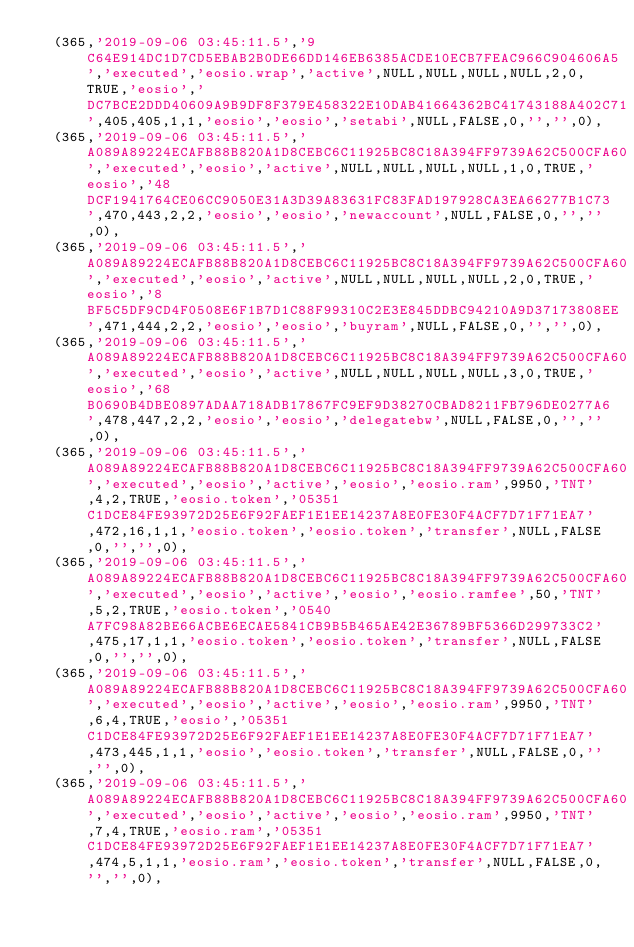Convert code to text. <code><loc_0><loc_0><loc_500><loc_500><_SQL_>  (365,'2019-09-06 03:45:11.5','9C64E914DC1D7CD5EBAB2B0DE66DD146EB6385ACDE10ECB7FEAC966C904606A5','executed','eosio.wrap','active',NULL,NULL,NULL,NULL,2,0,TRUE,'eosio','DC7BCE2DDD40609A9B9DF8F379E458322E10DAB41664362BC41743188A402C71',405,405,1,1,'eosio','eosio','setabi',NULL,FALSE,0,'','',0),
  (365,'2019-09-06 03:45:11.5','A089A89224ECAFB88B820A1D8CEBC6C11925BC8C18A394FF9739A62C500CFA60','executed','eosio','active',NULL,NULL,NULL,NULL,1,0,TRUE,'eosio','48DCF1941764CE06CC9050E31A3D39A83631FC83FAD197928CA3EA66277B1C73',470,443,2,2,'eosio','eosio','newaccount',NULL,FALSE,0,'','',0),
  (365,'2019-09-06 03:45:11.5','A089A89224ECAFB88B820A1D8CEBC6C11925BC8C18A394FF9739A62C500CFA60','executed','eosio','active',NULL,NULL,NULL,NULL,2,0,TRUE,'eosio','8BF5C5DF9CD4F0508E6F1B7D1C88F99310C2E3E845DDBC94210A9D37173808EE',471,444,2,2,'eosio','eosio','buyram',NULL,FALSE,0,'','',0),
  (365,'2019-09-06 03:45:11.5','A089A89224ECAFB88B820A1D8CEBC6C11925BC8C18A394FF9739A62C500CFA60','executed','eosio','active',NULL,NULL,NULL,NULL,3,0,TRUE,'eosio','68B0690B4DBE0897ADAA718ADB17867FC9EF9D38270CBAD8211FB796DE0277A6',478,447,2,2,'eosio','eosio','delegatebw',NULL,FALSE,0,'','',0),
  (365,'2019-09-06 03:45:11.5','A089A89224ECAFB88B820A1D8CEBC6C11925BC8C18A394FF9739A62C500CFA60','executed','eosio','active','eosio','eosio.ram',9950,'TNT',4,2,TRUE,'eosio.token','05351C1DCE84FE93972D25E6F92FAEF1E1EE14237A8E0FE30F4ACF7D71F71EA7',472,16,1,1,'eosio.token','eosio.token','transfer',NULL,FALSE,0,'','',0),
  (365,'2019-09-06 03:45:11.5','A089A89224ECAFB88B820A1D8CEBC6C11925BC8C18A394FF9739A62C500CFA60','executed','eosio','active','eosio','eosio.ramfee',50,'TNT',5,2,TRUE,'eosio.token','0540A7FC98A82BE66ACBE6ECAE5841CB9B5B465AE42E36789BF5366D299733C2',475,17,1,1,'eosio.token','eosio.token','transfer',NULL,FALSE,0,'','',0),
  (365,'2019-09-06 03:45:11.5','A089A89224ECAFB88B820A1D8CEBC6C11925BC8C18A394FF9739A62C500CFA60','executed','eosio','active','eosio','eosio.ram',9950,'TNT',6,4,TRUE,'eosio','05351C1DCE84FE93972D25E6F92FAEF1E1EE14237A8E0FE30F4ACF7D71F71EA7',473,445,1,1,'eosio','eosio.token','transfer',NULL,FALSE,0,'','',0),
  (365,'2019-09-06 03:45:11.5','A089A89224ECAFB88B820A1D8CEBC6C11925BC8C18A394FF9739A62C500CFA60','executed','eosio','active','eosio','eosio.ram',9950,'TNT',7,4,TRUE,'eosio.ram','05351C1DCE84FE93972D25E6F92FAEF1E1EE14237A8E0FE30F4ACF7D71F71EA7',474,5,1,1,'eosio.ram','eosio.token','transfer',NULL,FALSE,0,'','',0),</code> 